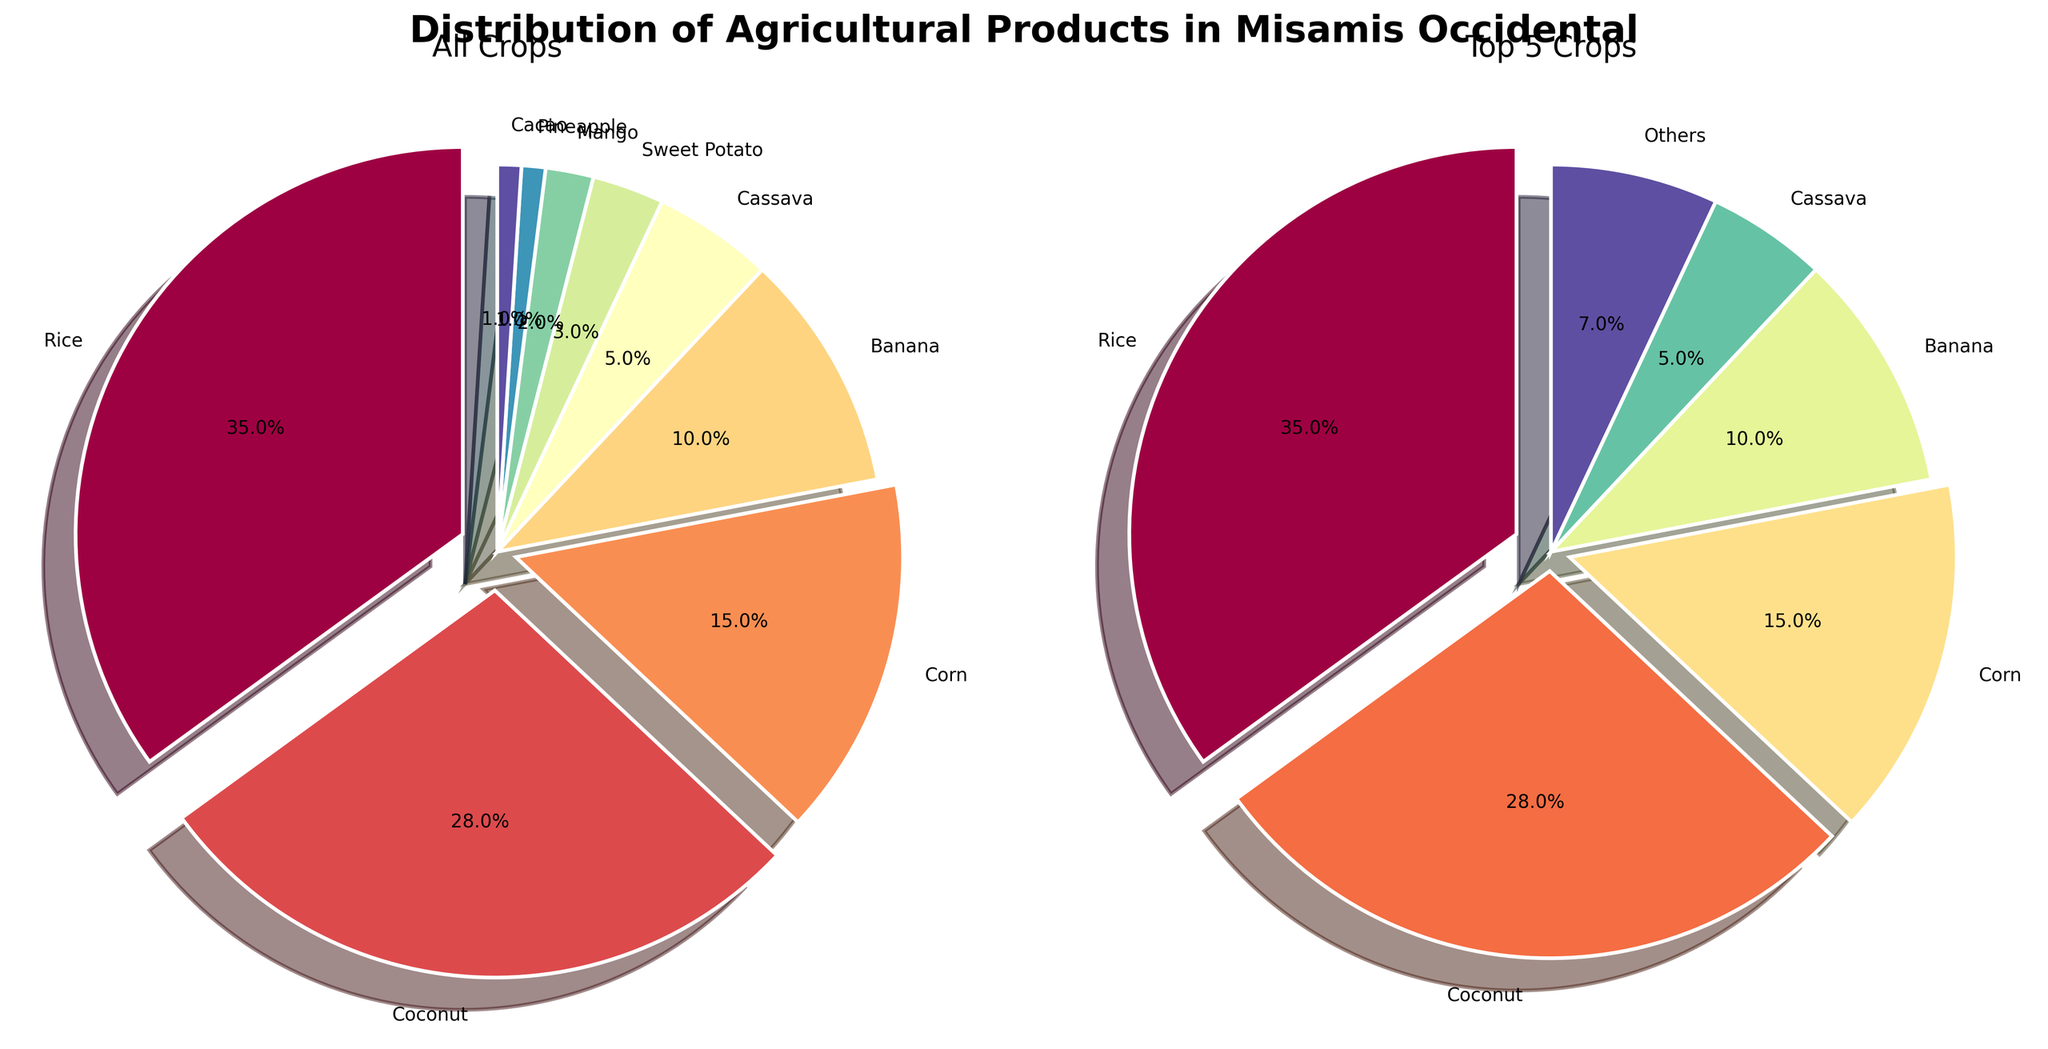What is the title of the subplot? The title is displayed at the top of the subplot. It reads "Distribution of Agricultural Products in Misamis Occidental" which directly tells us about the content of the subplot.
Answer: Distribution of Agricultural Products in Misamis Occidental How many crop types are displayed in the first pie chart (All Crops)? The first pie chart includes all the crop categories. Counting the segments in the first pie chart tells us there are 9 crop types.
Answer: 9 Which crop has the highest percentage in the first pie chart? The first pie chart shows the percentage of each crop with labels. Rice has the highest percentage at 35%.
Answer: Rice How many crop types constitute the "Top 5 Crops" in the second pie chart? The second pie chart is labeled "Top 5 Crops". Counting the segments which are specifically labeled crops, excluding the 'Others' category, we see there are 5 segments.
Answer: 5 What is the combined percentage of Coconut and Corn in the first pie chart? From the first pie chart, Coconut is 28% and Corn is 15%. Adding these together: 28 + 15 = 43%.
Answer: 43% Which crop has the smallest representation and what is its percentage? Both Mango and Pineapple have the smallest representation with 1% each. This is shown in the first pie chart with labeled percentages.
Answer: Mango, Pineapple, 1% What is the percentage representation of 'Others' in the second pie chart? The second pie chart has a segment labeled 'Others'. According to our data, 'Others' include crops not in the top 5, so adding percentages for Sweet Potato, Mango, Pineapple, and Cacao (3 + 2 + 1 + 1 = 7%) forms the final percentage.
Answer: 7% Which crop is the second most prevalent, and what is its percentage? According to the first pie chart, Coconut is the second most prevalent crop with a percentage of 28%.
Answer: Coconut, 28% Compare the percentage of Cassava and Banana. Which one has a higher percentage? The pie chart labels show Banana at 10% and Cassava at 5%. Clearly, Banana has a higher percentage than Cassava.
Answer: Banana What percentage of agricultural products do the top three crops (Rice, Coconut, Corn) make up in total? Summing the percentages of the top three crops: Rice (35%), Coconut (28%), Corn (15%) from the first pie chart, we calculate 35 + 28 + 15 = 78%.
Answer: 78% 